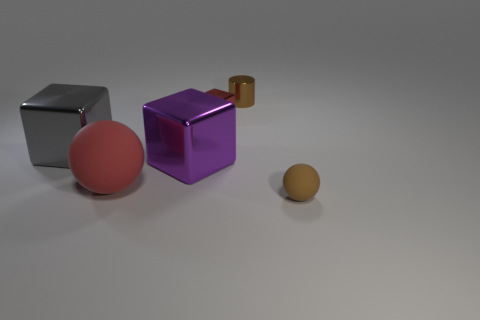How many small things have the same material as the tiny cylinder?
Provide a succinct answer. 1. How many objects are either red matte spheres or cubes on the right side of the gray cube?
Ensure brevity in your answer.  3. There is a small metallic object in front of the brown thing that is behind the matte object that is left of the purple thing; what is its color?
Provide a succinct answer. Red. There is a metallic cube in front of the gray object; how big is it?
Offer a very short reply. Large. What number of small objects are either gray objects or blue matte cubes?
Your answer should be very brief. 0. There is a object that is both in front of the big purple block and on the left side of the tiny brown metallic cylinder; what color is it?
Your answer should be very brief. Red. Are there any tiny matte things of the same shape as the gray metallic thing?
Keep it short and to the point. No. What material is the small brown ball?
Keep it short and to the point. Rubber. Are there any tiny blocks to the left of the tiny rubber object?
Make the answer very short. Yes. Is the shape of the large purple thing the same as the small red shiny object?
Your answer should be compact. Yes. 